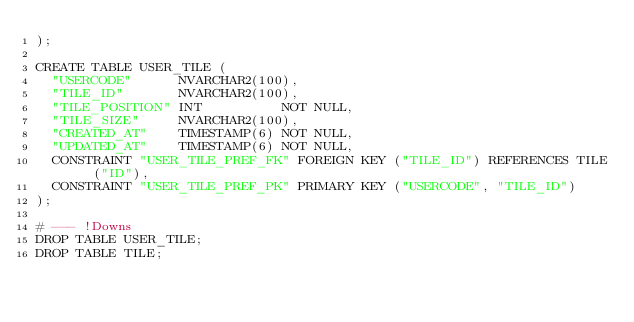Convert code to text. <code><loc_0><loc_0><loc_500><loc_500><_SQL_>);

CREATE TABLE USER_TILE (
  "USERCODE"      NVARCHAR2(100),
  "TILE_ID"       NVARCHAR2(100),
  "TILE_POSITION" INT          NOT NULL,
  "TILE_SIZE"     NVARCHAR2(100),
  "CREATED_AT"    TIMESTAMP(6) NOT NULL,
  "UPDATED_AT"    TIMESTAMP(6) NOT NULL,
  CONSTRAINT "USER_TILE_PREF_FK" FOREIGN KEY ("TILE_ID") REFERENCES TILE ("ID"),
  CONSTRAINT "USER_TILE_PREF_PK" PRIMARY KEY ("USERCODE", "TILE_ID")
);

# --- !Downs
DROP TABLE USER_TILE;
DROP TABLE TILE;
</code> 